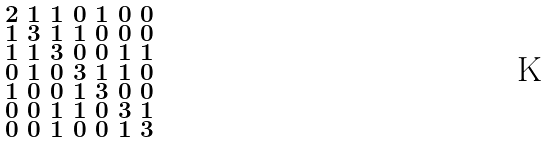<formula> <loc_0><loc_0><loc_500><loc_500>\begin{smallmatrix} 2 & 1 & 1 & 0 & 1 & 0 & 0 \\ 1 & 3 & 1 & 1 & 0 & 0 & 0 \\ 1 & 1 & 3 & 0 & 0 & 1 & 1 \\ 0 & 1 & 0 & 3 & 1 & 1 & 0 \\ 1 & 0 & 0 & 1 & 3 & 0 & 0 \\ 0 & 0 & 1 & 1 & 0 & 3 & 1 \\ 0 & 0 & 1 & 0 & 0 & 1 & 3 \end{smallmatrix}</formula> 